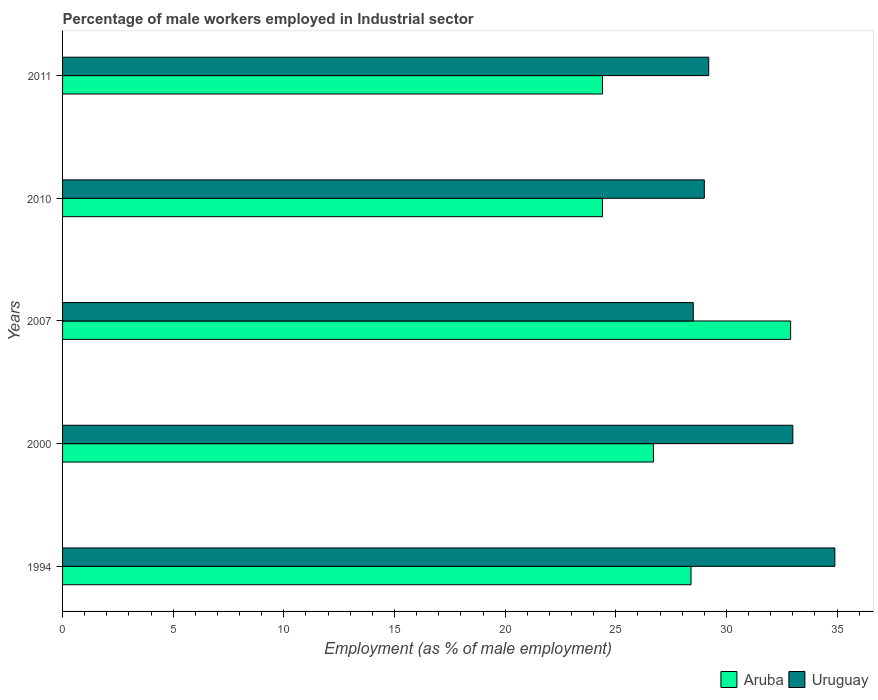How many different coloured bars are there?
Keep it short and to the point. 2. Are the number of bars per tick equal to the number of legend labels?
Ensure brevity in your answer.  Yes. Are the number of bars on each tick of the Y-axis equal?
Keep it short and to the point. Yes. How many bars are there on the 3rd tick from the top?
Keep it short and to the point. 2. How many bars are there on the 3rd tick from the bottom?
Ensure brevity in your answer.  2. What is the percentage of male workers employed in Industrial sector in Aruba in 2010?
Your answer should be very brief. 24.4. Across all years, what is the maximum percentage of male workers employed in Industrial sector in Uruguay?
Provide a short and direct response. 34.9. Across all years, what is the minimum percentage of male workers employed in Industrial sector in Aruba?
Provide a succinct answer. 24.4. In which year was the percentage of male workers employed in Industrial sector in Uruguay maximum?
Provide a short and direct response. 1994. In which year was the percentage of male workers employed in Industrial sector in Aruba minimum?
Make the answer very short. 2010. What is the total percentage of male workers employed in Industrial sector in Aruba in the graph?
Make the answer very short. 136.8. What is the difference between the percentage of male workers employed in Industrial sector in Uruguay in 2000 and that in 2011?
Provide a short and direct response. 3.8. What is the difference between the percentage of male workers employed in Industrial sector in Uruguay in 2010 and the percentage of male workers employed in Industrial sector in Aruba in 2007?
Your answer should be compact. -3.9. What is the average percentage of male workers employed in Industrial sector in Aruba per year?
Provide a succinct answer. 27.36. In the year 1994, what is the difference between the percentage of male workers employed in Industrial sector in Uruguay and percentage of male workers employed in Industrial sector in Aruba?
Keep it short and to the point. 6.5. What is the ratio of the percentage of male workers employed in Industrial sector in Uruguay in 2000 to that in 2011?
Ensure brevity in your answer.  1.13. Is the percentage of male workers employed in Industrial sector in Uruguay in 2007 less than that in 2011?
Keep it short and to the point. Yes. What is the difference between the highest and the second highest percentage of male workers employed in Industrial sector in Aruba?
Your answer should be compact. 4.5. What is the difference between the highest and the lowest percentage of male workers employed in Industrial sector in Uruguay?
Provide a succinct answer. 6.4. In how many years, is the percentage of male workers employed in Industrial sector in Uruguay greater than the average percentage of male workers employed in Industrial sector in Uruguay taken over all years?
Ensure brevity in your answer.  2. Is the sum of the percentage of male workers employed in Industrial sector in Aruba in 1994 and 2000 greater than the maximum percentage of male workers employed in Industrial sector in Uruguay across all years?
Provide a succinct answer. Yes. What does the 1st bar from the top in 2011 represents?
Make the answer very short. Uruguay. What does the 1st bar from the bottom in 2010 represents?
Offer a very short reply. Aruba. Are all the bars in the graph horizontal?
Give a very brief answer. Yes. How many years are there in the graph?
Ensure brevity in your answer.  5. Are the values on the major ticks of X-axis written in scientific E-notation?
Give a very brief answer. No. Does the graph contain any zero values?
Give a very brief answer. No. Does the graph contain grids?
Ensure brevity in your answer.  No. Where does the legend appear in the graph?
Keep it short and to the point. Bottom right. What is the title of the graph?
Provide a short and direct response. Percentage of male workers employed in Industrial sector. Does "Europe(developing only)" appear as one of the legend labels in the graph?
Ensure brevity in your answer.  No. What is the label or title of the X-axis?
Your answer should be compact. Employment (as % of male employment). What is the Employment (as % of male employment) of Aruba in 1994?
Provide a succinct answer. 28.4. What is the Employment (as % of male employment) in Uruguay in 1994?
Give a very brief answer. 34.9. What is the Employment (as % of male employment) in Aruba in 2000?
Keep it short and to the point. 26.7. What is the Employment (as % of male employment) in Uruguay in 2000?
Keep it short and to the point. 33. What is the Employment (as % of male employment) of Aruba in 2007?
Provide a succinct answer. 32.9. What is the Employment (as % of male employment) of Uruguay in 2007?
Ensure brevity in your answer.  28.5. What is the Employment (as % of male employment) in Aruba in 2010?
Ensure brevity in your answer.  24.4. What is the Employment (as % of male employment) of Uruguay in 2010?
Offer a very short reply. 29. What is the Employment (as % of male employment) in Aruba in 2011?
Your answer should be compact. 24.4. What is the Employment (as % of male employment) of Uruguay in 2011?
Provide a short and direct response. 29.2. Across all years, what is the maximum Employment (as % of male employment) in Aruba?
Your answer should be very brief. 32.9. Across all years, what is the maximum Employment (as % of male employment) in Uruguay?
Keep it short and to the point. 34.9. Across all years, what is the minimum Employment (as % of male employment) in Aruba?
Offer a terse response. 24.4. What is the total Employment (as % of male employment) of Aruba in the graph?
Provide a short and direct response. 136.8. What is the total Employment (as % of male employment) of Uruguay in the graph?
Your answer should be very brief. 154.6. What is the difference between the Employment (as % of male employment) in Uruguay in 1994 and that in 2000?
Offer a very short reply. 1.9. What is the difference between the Employment (as % of male employment) of Aruba in 1994 and that in 2007?
Provide a short and direct response. -4.5. What is the difference between the Employment (as % of male employment) in Uruguay in 1994 and that in 2007?
Make the answer very short. 6.4. What is the difference between the Employment (as % of male employment) in Uruguay in 1994 and that in 2011?
Ensure brevity in your answer.  5.7. What is the difference between the Employment (as % of male employment) of Aruba in 2000 and that in 2007?
Offer a very short reply. -6.2. What is the difference between the Employment (as % of male employment) in Uruguay in 2000 and that in 2007?
Offer a very short reply. 4.5. What is the difference between the Employment (as % of male employment) in Uruguay in 2000 and that in 2010?
Keep it short and to the point. 4. What is the difference between the Employment (as % of male employment) in Uruguay in 2007 and that in 2010?
Provide a succinct answer. -0.5. What is the difference between the Employment (as % of male employment) in Aruba in 2007 and that in 2011?
Ensure brevity in your answer.  8.5. What is the difference between the Employment (as % of male employment) of Uruguay in 2007 and that in 2011?
Ensure brevity in your answer.  -0.7. What is the difference between the Employment (as % of male employment) of Uruguay in 2010 and that in 2011?
Make the answer very short. -0.2. What is the difference between the Employment (as % of male employment) of Aruba in 1994 and the Employment (as % of male employment) of Uruguay in 2000?
Make the answer very short. -4.6. What is the difference between the Employment (as % of male employment) in Aruba in 1994 and the Employment (as % of male employment) in Uruguay in 2010?
Offer a very short reply. -0.6. What is the difference between the Employment (as % of male employment) in Aruba in 1994 and the Employment (as % of male employment) in Uruguay in 2011?
Provide a succinct answer. -0.8. What is the difference between the Employment (as % of male employment) in Aruba in 2000 and the Employment (as % of male employment) in Uruguay in 2010?
Ensure brevity in your answer.  -2.3. What is the difference between the Employment (as % of male employment) in Aruba in 2000 and the Employment (as % of male employment) in Uruguay in 2011?
Your response must be concise. -2.5. What is the difference between the Employment (as % of male employment) in Aruba in 2007 and the Employment (as % of male employment) in Uruguay in 2010?
Your answer should be compact. 3.9. What is the difference between the Employment (as % of male employment) in Aruba in 2007 and the Employment (as % of male employment) in Uruguay in 2011?
Make the answer very short. 3.7. What is the difference between the Employment (as % of male employment) of Aruba in 2010 and the Employment (as % of male employment) of Uruguay in 2011?
Keep it short and to the point. -4.8. What is the average Employment (as % of male employment) in Aruba per year?
Ensure brevity in your answer.  27.36. What is the average Employment (as % of male employment) in Uruguay per year?
Your response must be concise. 30.92. In the year 1994, what is the difference between the Employment (as % of male employment) of Aruba and Employment (as % of male employment) of Uruguay?
Keep it short and to the point. -6.5. What is the ratio of the Employment (as % of male employment) of Aruba in 1994 to that in 2000?
Provide a short and direct response. 1.06. What is the ratio of the Employment (as % of male employment) of Uruguay in 1994 to that in 2000?
Ensure brevity in your answer.  1.06. What is the ratio of the Employment (as % of male employment) in Aruba in 1994 to that in 2007?
Ensure brevity in your answer.  0.86. What is the ratio of the Employment (as % of male employment) in Uruguay in 1994 to that in 2007?
Your response must be concise. 1.22. What is the ratio of the Employment (as % of male employment) in Aruba in 1994 to that in 2010?
Provide a succinct answer. 1.16. What is the ratio of the Employment (as % of male employment) of Uruguay in 1994 to that in 2010?
Offer a very short reply. 1.2. What is the ratio of the Employment (as % of male employment) of Aruba in 1994 to that in 2011?
Your response must be concise. 1.16. What is the ratio of the Employment (as % of male employment) in Uruguay in 1994 to that in 2011?
Offer a very short reply. 1.2. What is the ratio of the Employment (as % of male employment) of Aruba in 2000 to that in 2007?
Keep it short and to the point. 0.81. What is the ratio of the Employment (as % of male employment) in Uruguay in 2000 to that in 2007?
Your answer should be compact. 1.16. What is the ratio of the Employment (as % of male employment) of Aruba in 2000 to that in 2010?
Offer a terse response. 1.09. What is the ratio of the Employment (as % of male employment) of Uruguay in 2000 to that in 2010?
Provide a succinct answer. 1.14. What is the ratio of the Employment (as % of male employment) of Aruba in 2000 to that in 2011?
Your response must be concise. 1.09. What is the ratio of the Employment (as % of male employment) in Uruguay in 2000 to that in 2011?
Your response must be concise. 1.13. What is the ratio of the Employment (as % of male employment) of Aruba in 2007 to that in 2010?
Offer a terse response. 1.35. What is the ratio of the Employment (as % of male employment) in Uruguay in 2007 to that in 2010?
Ensure brevity in your answer.  0.98. What is the ratio of the Employment (as % of male employment) of Aruba in 2007 to that in 2011?
Your response must be concise. 1.35. What is the ratio of the Employment (as % of male employment) in Aruba in 2010 to that in 2011?
Ensure brevity in your answer.  1. What is the ratio of the Employment (as % of male employment) of Uruguay in 2010 to that in 2011?
Your answer should be compact. 0.99. What is the difference between the highest and the second highest Employment (as % of male employment) in Aruba?
Provide a short and direct response. 4.5. What is the difference between the highest and the lowest Employment (as % of male employment) in Aruba?
Offer a very short reply. 8.5. What is the difference between the highest and the lowest Employment (as % of male employment) in Uruguay?
Your answer should be compact. 6.4. 